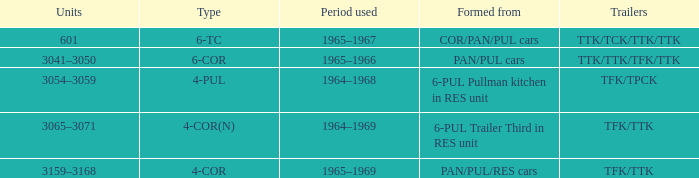Identify the trailers created from pan/pul/res vehicles. TFK/TTK. 